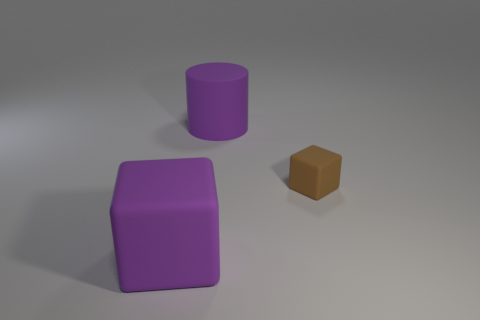There is another matte object that is the same shape as the brown matte thing; what is its size?
Keep it short and to the point. Large. Are there any other things that have the same size as the purple rubber cube?
Your answer should be very brief. Yes. Is the number of big purple rubber cylinders that are on the right side of the small object less than the number of big purple cubes on the right side of the big cylinder?
Provide a succinct answer. No. What number of big purple rubber blocks are in front of the big rubber cylinder?
Offer a very short reply. 1. Is the shape of the purple matte thing in front of the large matte cylinder the same as the thing that is on the right side of the matte cylinder?
Ensure brevity in your answer.  Yes. What number of other objects are the same color as the big cylinder?
Your response must be concise. 1. What is the material of the cube behind the large rubber object left of the purple object that is behind the purple block?
Provide a short and direct response. Rubber. There is a purple object that is to the left of the big purple thing that is behind the large purple cube; what is its material?
Offer a very short reply. Rubber. Is the number of big things behind the rubber cylinder less than the number of big purple metal cylinders?
Your answer should be compact. No. There is a thing that is behind the small block; what is its shape?
Give a very brief answer. Cylinder. 